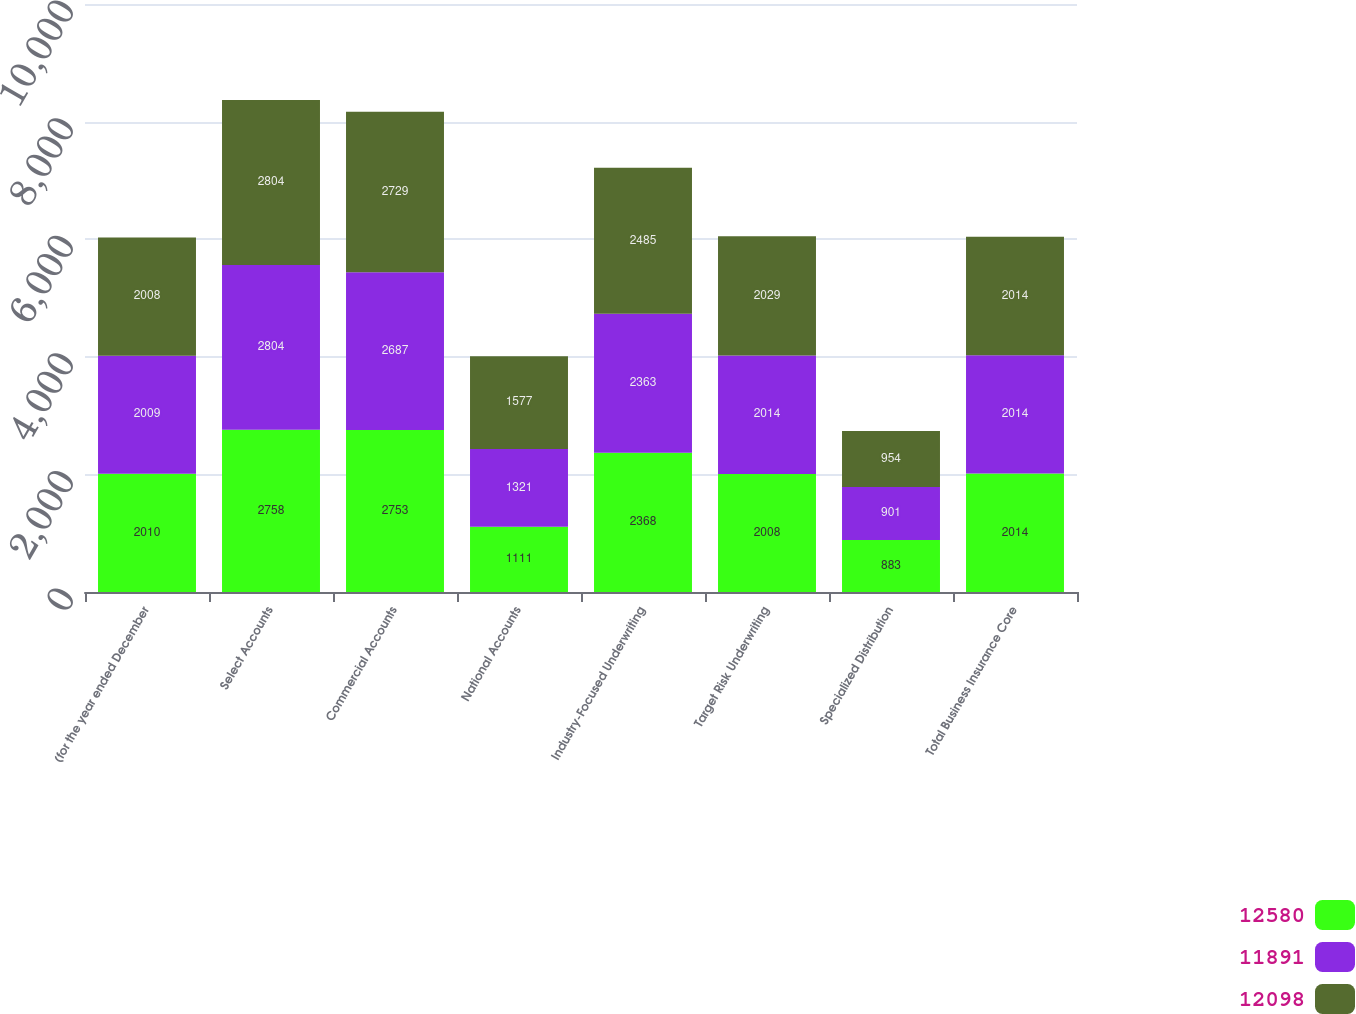Convert chart. <chart><loc_0><loc_0><loc_500><loc_500><stacked_bar_chart><ecel><fcel>(for the year ended December<fcel>Select Accounts<fcel>Commercial Accounts<fcel>National Accounts<fcel>Industry-Focused Underwriting<fcel>Target Risk Underwriting<fcel>Specialized Distribution<fcel>Total Business Insurance Core<nl><fcel>12580<fcel>2010<fcel>2758<fcel>2753<fcel>1111<fcel>2368<fcel>2008<fcel>883<fcel>2014<nl><fcel>11891<fcel>2009<fcel>2804<fcel>2687<fcel>1321<fcel>2363<fcel>2014<fcel>901<fcel>2014<nl><fcel>12098<fcel>2008<fcel>2804<fcel>2729<fcel>1577<fcel>2485<fcel>2029<fcel>954<fcel>2014<nl></chart> 